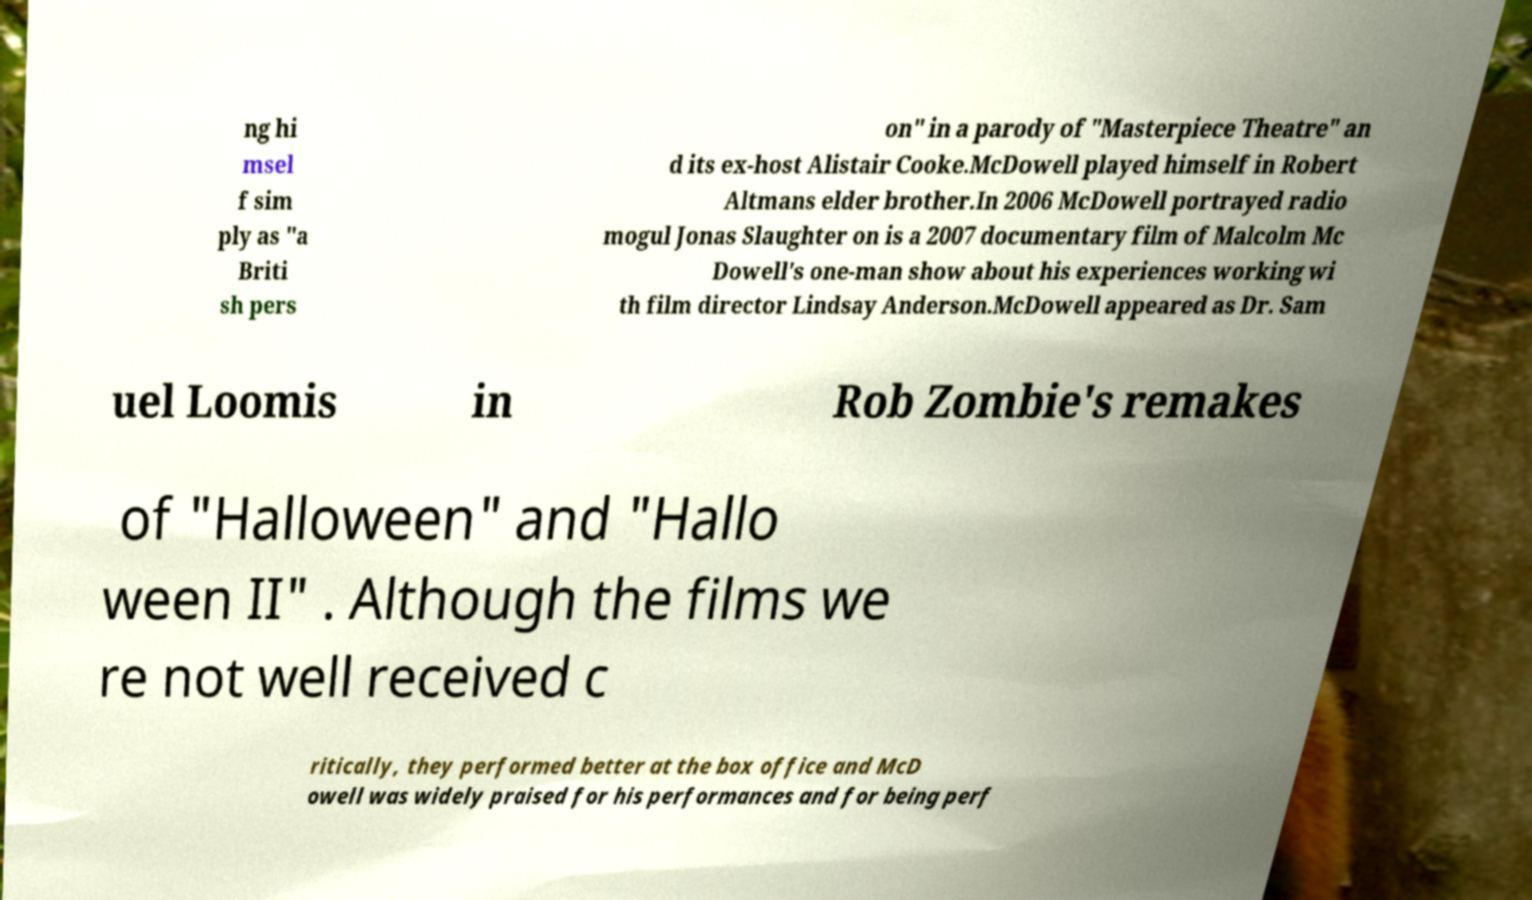I need the written content from this picture converted into text. Can you do that? ng hi msel f sim ply as "a Briti sh pers on" in a parody of "Masterpiece Theatre" an d its ex-host Alistair Cooke.McDowell played himself in Robert Altmans elder brother.In 2006 McDowell portrayed radio mogul Jonas Slaughter on is a 2007 documentary film of Malcolm Mc Dowell's one-man show about his experiences working wi th film director Lindsay Anderson.McDowell appeared as Dr. Sam uel Loomis in Rob Zombie's remakes of "Halloween" and "Hallo ween II" . Although the films we re not well received c ritically, they performed better at the box office and McD owell was widely praised for his performances and for being perf 